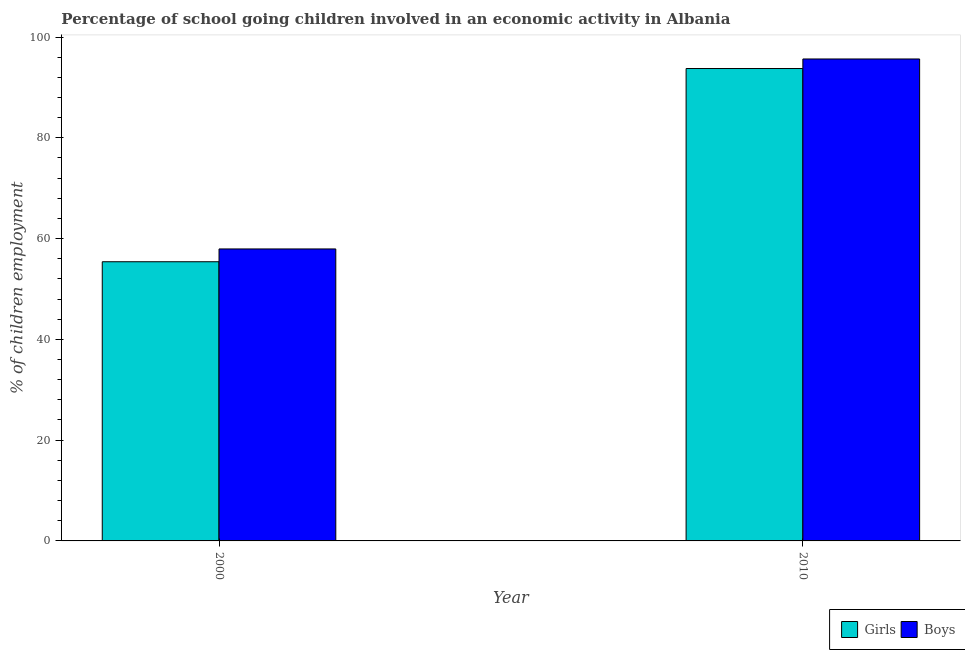How many groups of bars are there?
Your answer should be compact. 2. Are the number of bars per tick equal to the number of legend labels?
Provide a short and direct response. Yes. How many bars are there on the 1st tick from the left?
Your answer should be very brief. 2. How many bars are there on the 2nd tick from the right?
Make the answer very short. 2. What is the label of the 2nd group of bars from the left?
Your response must be concise. 2010. What is the percentage of school going boys in 2010?
Keep it short and to the point. 95.65. Across all years, what is the maximum percentage of school going girls?
Provide a short and direct response. 93.76. Across all years, what is the minimum percentage of school going boys?
Your answer should be very brief. 57.95. In which year was the percentage of school going boys maximum?
Offer a terse response. 2010. What is the total percentage of school going girls in the graph?
Your response must be concise. 149.17. What is the difference between the percentage of school going girls in 2000 and that in 2010?
Provide a short and direct response. -38.35. What is the difference between the percentage of school going boys in 2010 and the percentage of school going girls in 2000?
Provide a short and direct response. 37.7. What is the average percentage of school going girls per year?
Make the answer very short. 74.58. In the year 2010, what is the difference between the percentage of school going boys and percentage of school going girls?
Offer a terse response. 0. What is the ratio of the percentage of school going boys in 2000 to that in 2010?
Offer a very short reply. 0.61. Is the percentage of school going girls in 2000 less than that in 2010?
Your answer should be compact. Yes. In how many years, is the percentage of school going girls greater than the average percentage of school going girls taken over all years?
Provide a succinct answer. 1. What does the 1st bar from the left in 2000 represents?
Your answer should be compact. Girls. What does the 2nd bar from the right in 2010 represents?
Keep it short and to the point. Girls. Are all the bars in the graph horizontal?
Provide a short and direct response. No. Does the graph contain any zero values?
Offer a very short reply. No. Does the graph contain grids?
Offer a very short reply. No. How many legend labels are there?
Give a very brief answer. 2. What is the title of the graph?
Keep it short and to the point. Percentage of school going children involved in an economic activity in Albania. Does "Fertility rate" appear as one of the legend labels in the graph?
Provide a succinct answer. No. What is the label or title of the X-axis?
Provide a succinct answer. Year. What is the label or title of the Y-axis?
Provide a succinct answer. % of children employment. What is the % of children employment in Girls in 2000?
Provide a short and direct response. 55.41. What is the % of children employment in Boys in 2000?
Your response must be concise. 57.95. What is the % of children employment of Girls in 2010?
Your response must be concise. 93.76. What is the % of children employment of Boys in 2010?
Your answer should be very brief. 95.65. Across all years, what is the maximum % of children employment of Girls?
Make the answer very short. 93.76. Across all years, what is the maximum % of children employment in Boys?
Keep it short and to the point. 95.65. Across all years, what is the minimum % of children employment in Girls?
Offer a terse response. 55.41. Across all years, what is the minimum % of children employment of Boys?
Give a very brief answer. 57.95. What is the total % of children employment of Girls in the graph?
Your answer should be very brief. 149.17. What is the total % of children employment of Boys in the graph?
Your response must be concise. 153.6. What is the difference between the % of children employment in Girls in 2000 and that in 2010?
Offer a very short reply. -38.35. What is the difference between the % of children employment of Boys in 2000 and that in 2010?
Make the answer very short. -37.7. What is the difference between the % of children employment of Girls in 2000 and the % of children employment of Boys in 2010?
Provide a short and direct response. -40.24. What is the average % of children employment of Girls per year?
Provide a short and direct response. 74.58. What is the average % of children employment in Boys per year?
Provide a succinct answer. 76.8. In the year 2000, what is the difference between the % of children employment in Girls and % of children employment in Boys?
Offer a very short reply. -2.54. In the year 2010, what is the difference between the % of children employment in Girls and % of children employment in Boys?
Provide a short and direct response. -1.89. What is the ratio of the % of children employment in Girls in 2000 to that in 2010?
Offer a terse response. 0.59. What is the ratio of the % of children employment in Boys in 2000 to that in 2010?
Offer a terse response. 0.61. What is the difference between the highest and the second highest % of children employment of Girls?
Offer a terse response. 38.35. What is the difference between the highest and the second highest % of children employment of Boys?
Make the answer very short. 37.7. What is the difference between the highest and the lowest % of children employment of Girls?
Your response must be concise. 38.35. What is the difference between the highest and the lowest % of children employment of Boys?
Your answer should be compact. 37.7. 